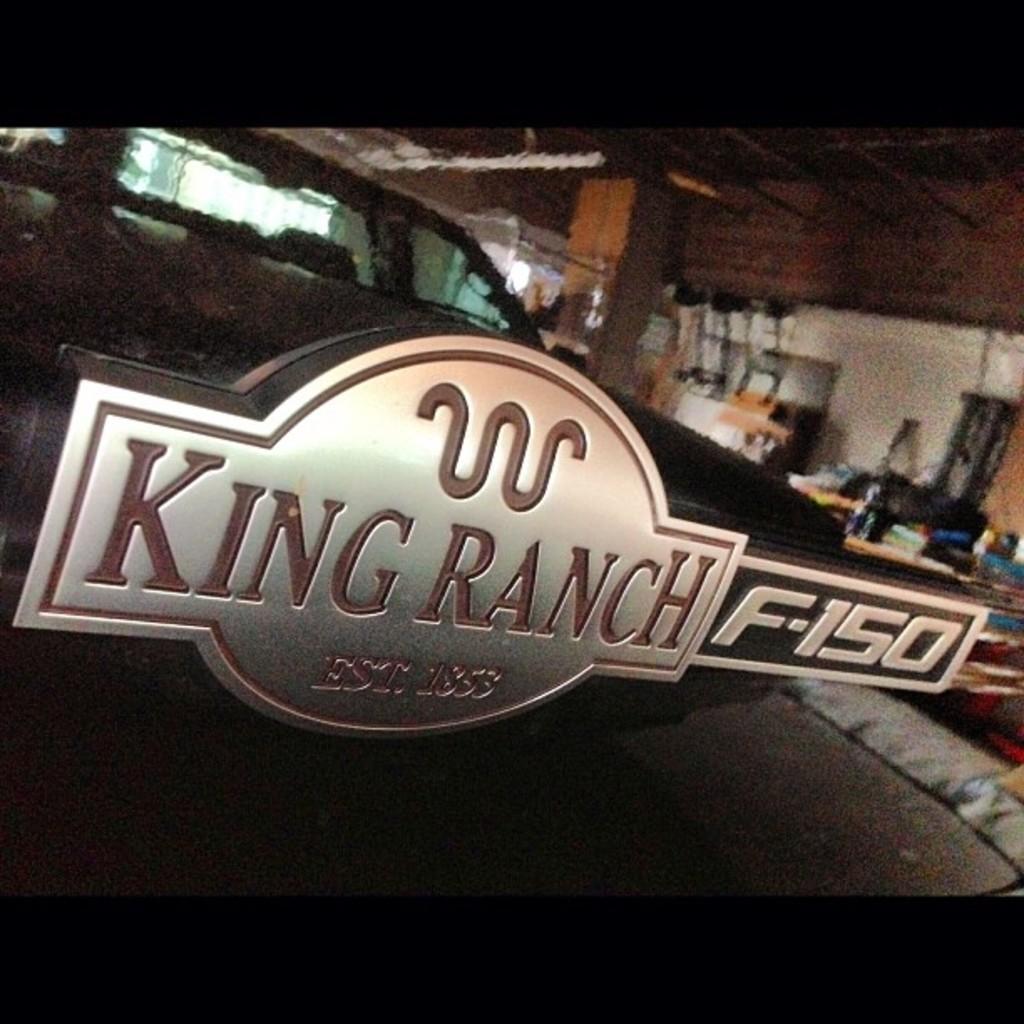How would you summarize this image in a sentence or two? This picture is taken inside the room. In this image, in the middle, we can see a board. On the board, we can see some text written on it. On the right side, we can see some objects. In the background, we can see a vehicle. At the top, we can see a pillar and a roof. 